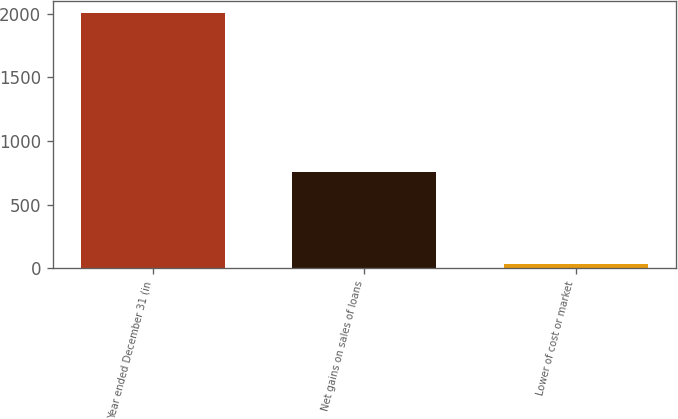Convert chart. <chart><loc_0><loc_0><loc_500><loc_500><bar_chart><fcel>Year ended December 31 (in<fcel>Net gains on sales of loans<fcel>Lower of cost or market<nl><fcel>2002<fcel>754<fcel>36<nl></chart> 